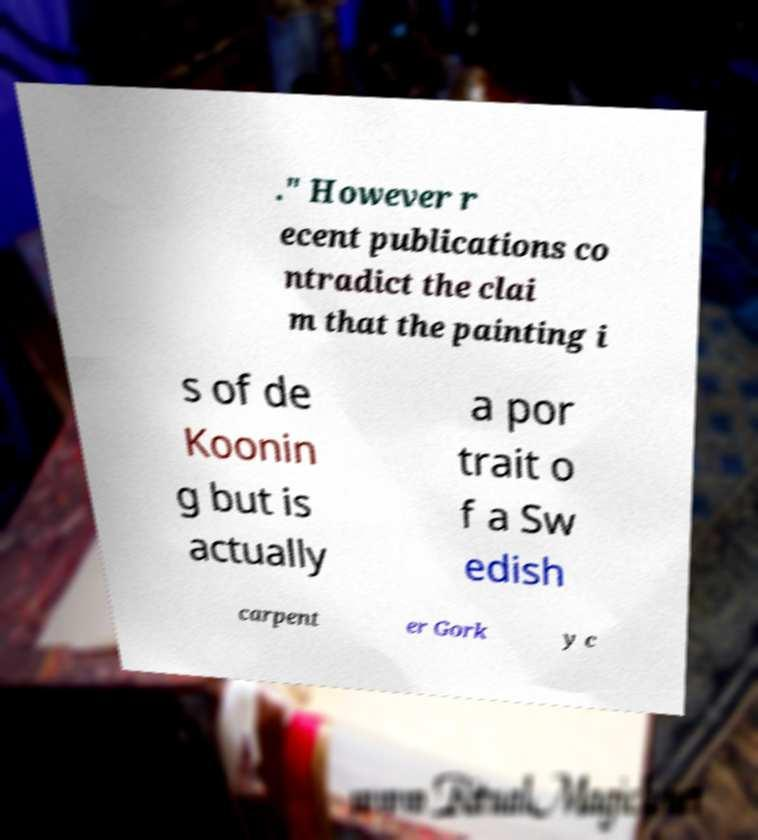Please read and relay the text visible in this image. What does it say? ." However r ecent publications co ntradict the clai m that the painting i s of de Koonin g but is actually a por trait o f a Sw edish carpent er Gork y c 